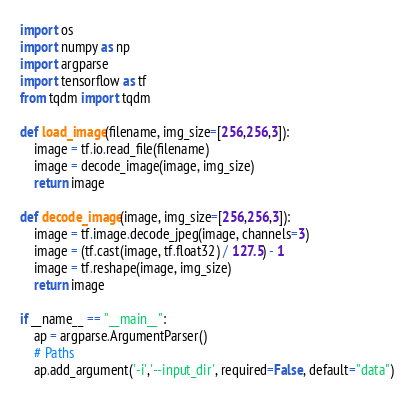<code> <loc_0><loc_0><loc_500><loc_500><_Python_>import os
import numpy as np
import argparse
import tensorflow as tf
from tqdm import tqdm

def load_image(filename, img_size=[256,256,3]):
    image = tf.io.read_file(filename)
    image = decode_image(image, img_size)
    return image

def decode_image(image, img_size=[256,256,3]):
    image = tf.image.decode_jpeg(image, channels=3)
    image = (tf.cast(image, tf.float32) / 127.5) - 1        
    image = tf.reshape(image, img_size)        
    return image

if __name__ == "__main__":
    ap = argparse.ArgumentParser()
    # Paths
    ap.add_argument('-i','--input_dir', required=False, default="data")</code> 